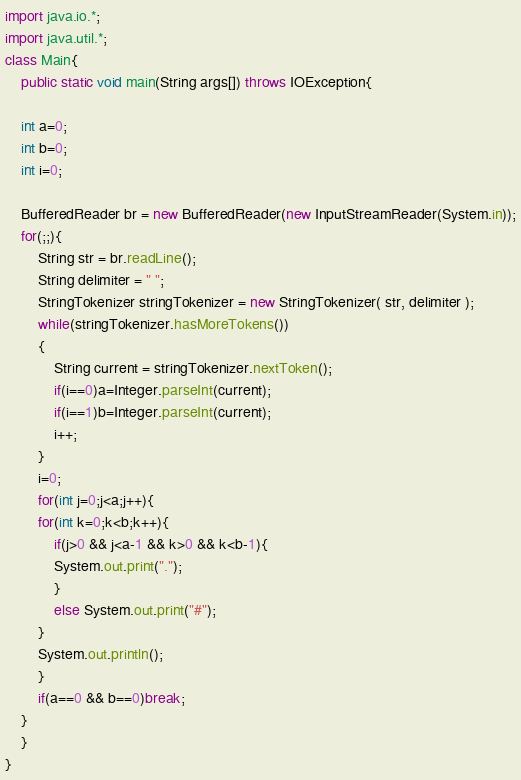<code> <loc_0><loc_0><loc_500><loc_500><_Java_>import java.io.*;
import java.util.*;
class Main{
    public static void main(String args[]) throws IOException{

	int a=0;
	int b=0;
	int i=0;

	BufferedReader br = new BufferedReader(new InputStreamReader(System.in));
	for(;;){
	    String str = br.readLine();
	    String delimiter = " ";
	    StringTokenizer stringTokenizer = new StringTokenizer( str, delimiter );
	    while(stringTokenizer.hasMoreTokens())
		{
		    String current = stringTokenizer.nextToken();
		    if(i==0)a=Integer.parseInt(current);
		    if(i==1)b=Integer.parseInt(current);
		    i++;
		}
	    i=0;
	    for(int j=0;j<a;j++){
		for(int k=0;k<b;k++){
		    if(j>0 && j<a-1 && k>0 && k<b-1){
			System.out.print(".");
		    }
		    else System.out.print("#");
		}
		System.out.println();
	    }
	    if(a==0 && b==0)break;
	}
    }
}</code> 